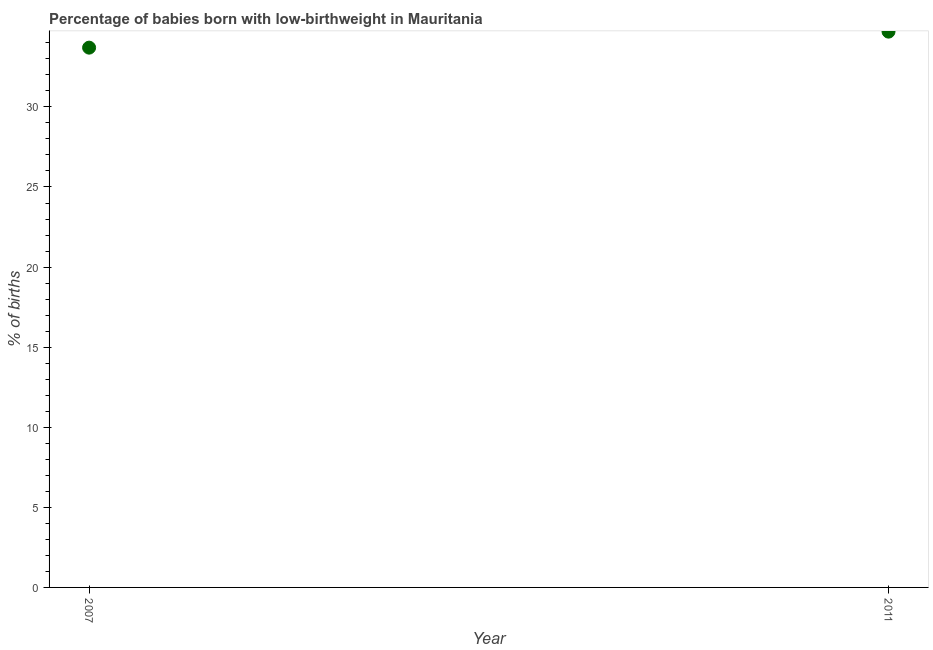What is the percentage of babies who were born with low-birthweight in 2007?
Your response must be concise. 33.7. Across all years, what is the maximum percentage of babies who were born with low-birthweight?
Your response must be concise. 34.7. Across all years, what is the minimum percentage of babies who were born with low-birthweight?
Ensure brevity in your answer.  33.7. What is the sum of the percentage of babies who were born with low-birthweight?
Your answer should be very brief. 68.4. What is the difference between the percentage of babies who were born with low-birthweight in 2007 and 2011?
Offer a very short reply. -1. What is the average percentage of babies who were born with low-birthweight per year?
Provide a succinct answer. 34.2. What is the median percentage of babies who were born with low-birthweight?
Keep it short and to the point. 34.2. What is the ratio of the percentage of babies who were born with low-birthweight in 2007 to that in 2011?
Your response must be concise. 0.97. Does the percentage of babies who were born with low-birthweight monotonically increase over the years?
Offer a very short reply. Yes. How many dotlines are there?
Ensure brevity in your answer.  1. How many years are there in the graph?
Offer a very short reply. 2. What is the difference between two consecutive major ticks on the Y-axis?
Give a very brief answer. 5. What is the title of the graph?
Your answer should be compact. Percentage of babies born with low-birthweight in Mauritania. What is the label or title of the X-axis?
Provide a succinct answer. Year. What is the label or title of the Y-axis?
Give a very brief answer. % of births. What is the % of births in 2007?
Offer a very short reply. 33.7. What is the % of births in 2011?
Your answer should be compact. 34.7. What is the ratio of the % of births in 2007 to that in 2011?
Ensure brevity in your answer.  0.97. 